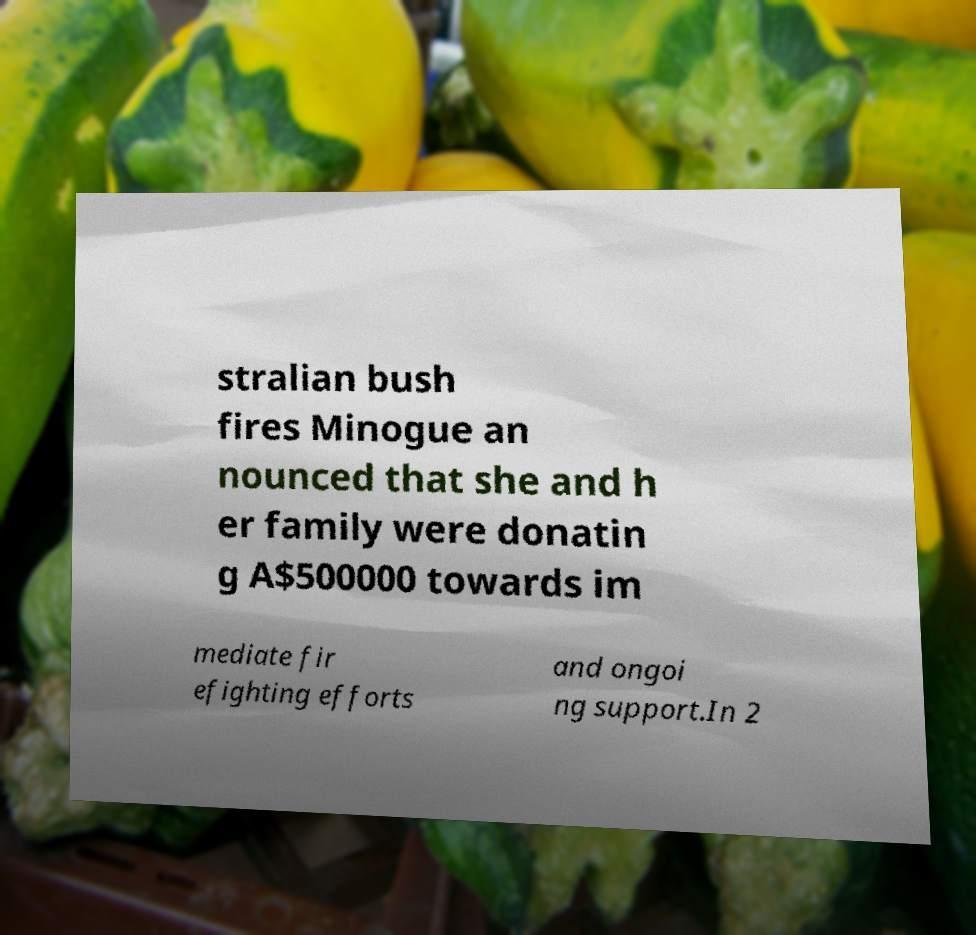Could you extract and type out the text from this image? stralian bush fires Minogue an nounced that she and h er family were donatin g A$500000 towards im mediate fir efighting efforts and ongoi ng support.In 2 